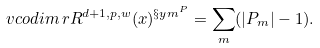Convert formula to latex. <formula><loc_0><loc_0><loc_500><loc_500>v c o d i m \, r R ^ { d + 1 , p , w } ( x ) ^ { \S y m ^ { P } } = \sum _ { m } ( | P _ { m } | - 1 ) .</formula> 